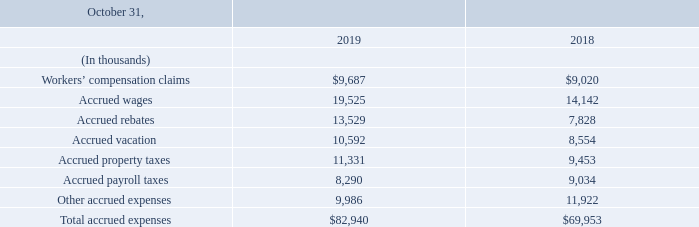5. Accrued expenses
Accrued expenses consisted of the following:
What is the Workers’ compensation claims for fiscal years 2019 and 2018 respectively?
Answer scale should be: thousand. $9,687, $9,020. What is the Accrued wages for fiscal years 2019 and 2018 respectively?
Answer scale should be: thousand. 19,525, 14,142. What does the table provide data about? Accrued expenses. What is the average Workers’ compensation claims for fiscal years 2019 and 2018?
Answer scale should be: thousand. (9,687+ 9,020)/2
Answer: 9353.5. What is the average Accrued payroll taxes for fiscal years 2019 and 2018?
Answer scale should be: thousand. (8,290+ 9,034)/2
Answer: 8662. What is the change in Total accrued expenses between fiscal years 2019 and 2018?
Answer scale should be: thousand. 82,940-69,953
Answer: 12987. 